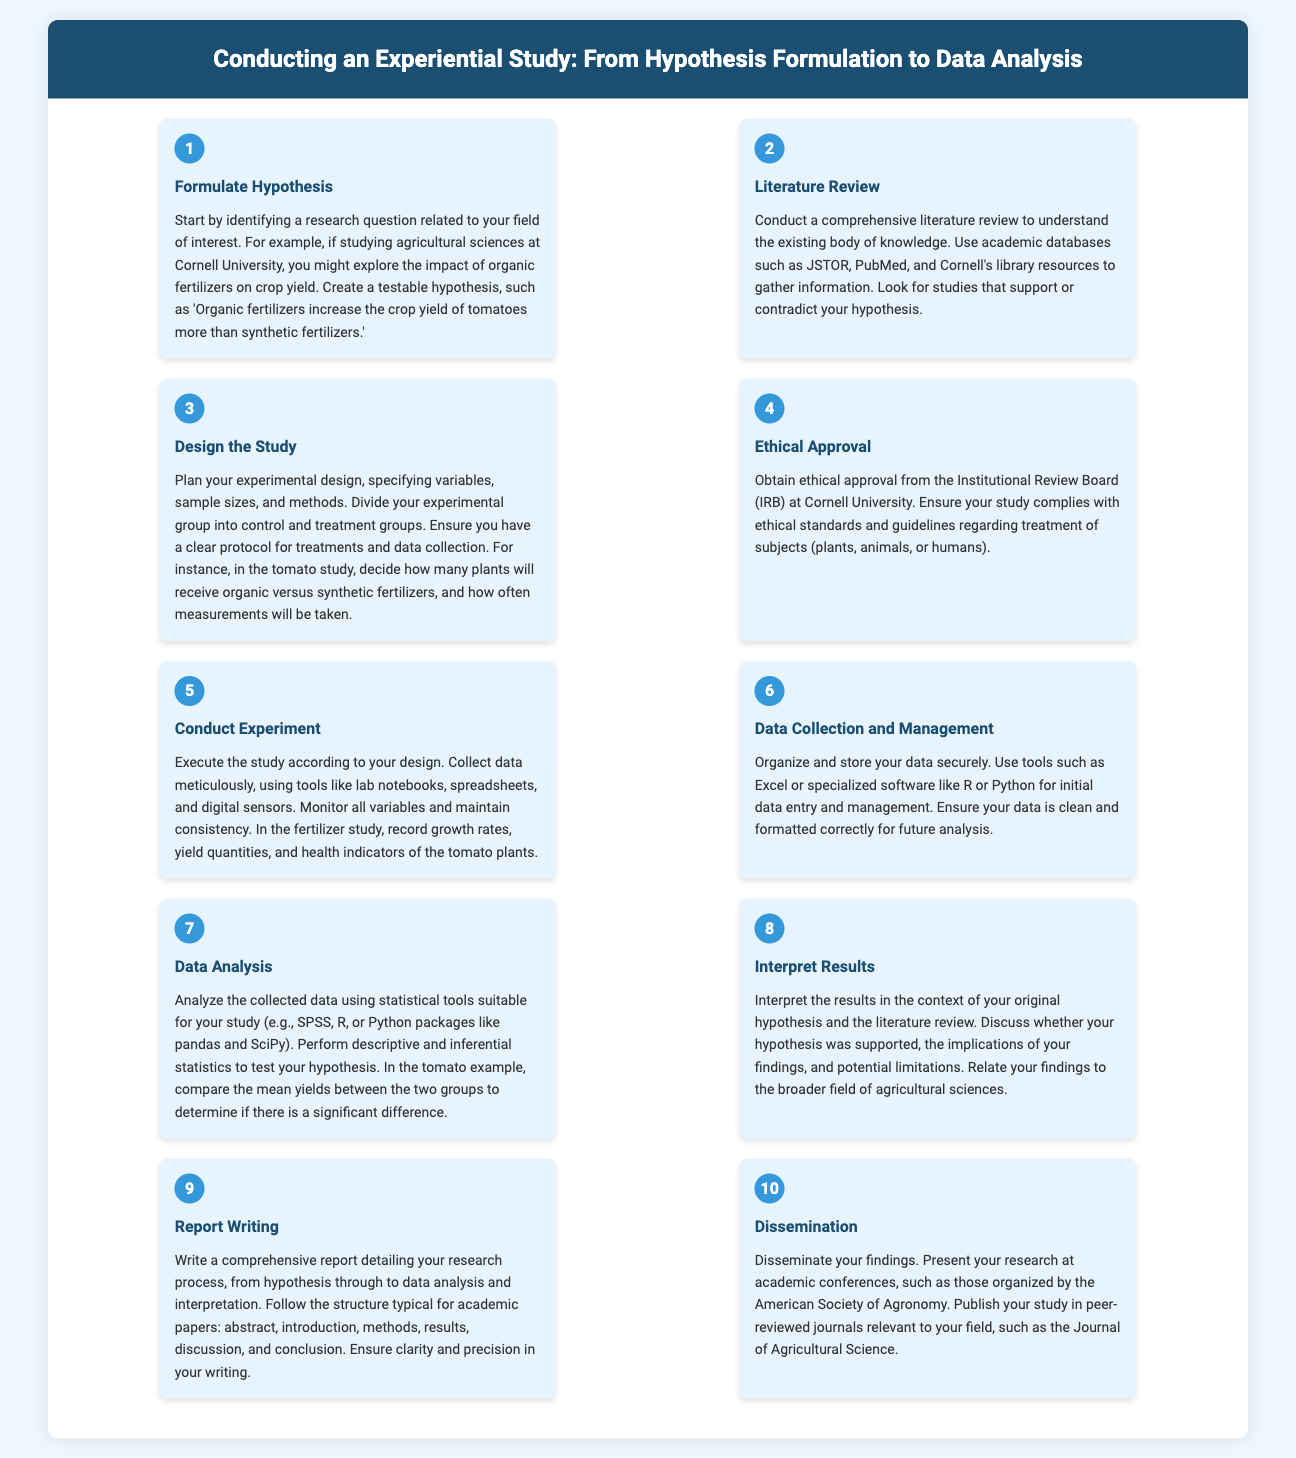What is the first step in conducting an experiential study? The first step is identified in the “Formulate Hypothesis” section of the document.
Answer: Formulate Hypothesis Which academic databases are recommended for literature review? The document mentions specific academic databases for gathering information.
Answer: JSTOR, PubMed How many groups should the experimental design include? The “Design the Study” step specifies dividing the experimental group into different types.
Answer: Control and treatment groups What does IRB stand for? The requirement for ethical approval is highlighted, and the acronym is explained in the document.
Answer: Institutional Review Board What is to be collected during the experiment according to the content? The content emphasizes the importance of specific data collection during the study.
Answer: Data Which statistical tools are suggested for data analysis? The “Data Analysis” section lists suitable statistical tools for analysis.
Answer: SPSS, R, Python packages What should the structure of the academic report include? The “Report Writing” step outlines the typical structure for academic papers.
Answer: Abstract, introduction, methods, results, discussion, conclusion What is the purpose of dissemination in this process? The last step discusses the intended outcomes after completing the study.
Answer: Present research findings At which type of events should the findings be presented? The dissemination step mentions specific venues for presenting research.
Answer: Academic conferences In which journal is the study recommended to be published? The final step advises publication in a specific type of journal relevant to the field.
Answer: Journal of Agricultural Science 